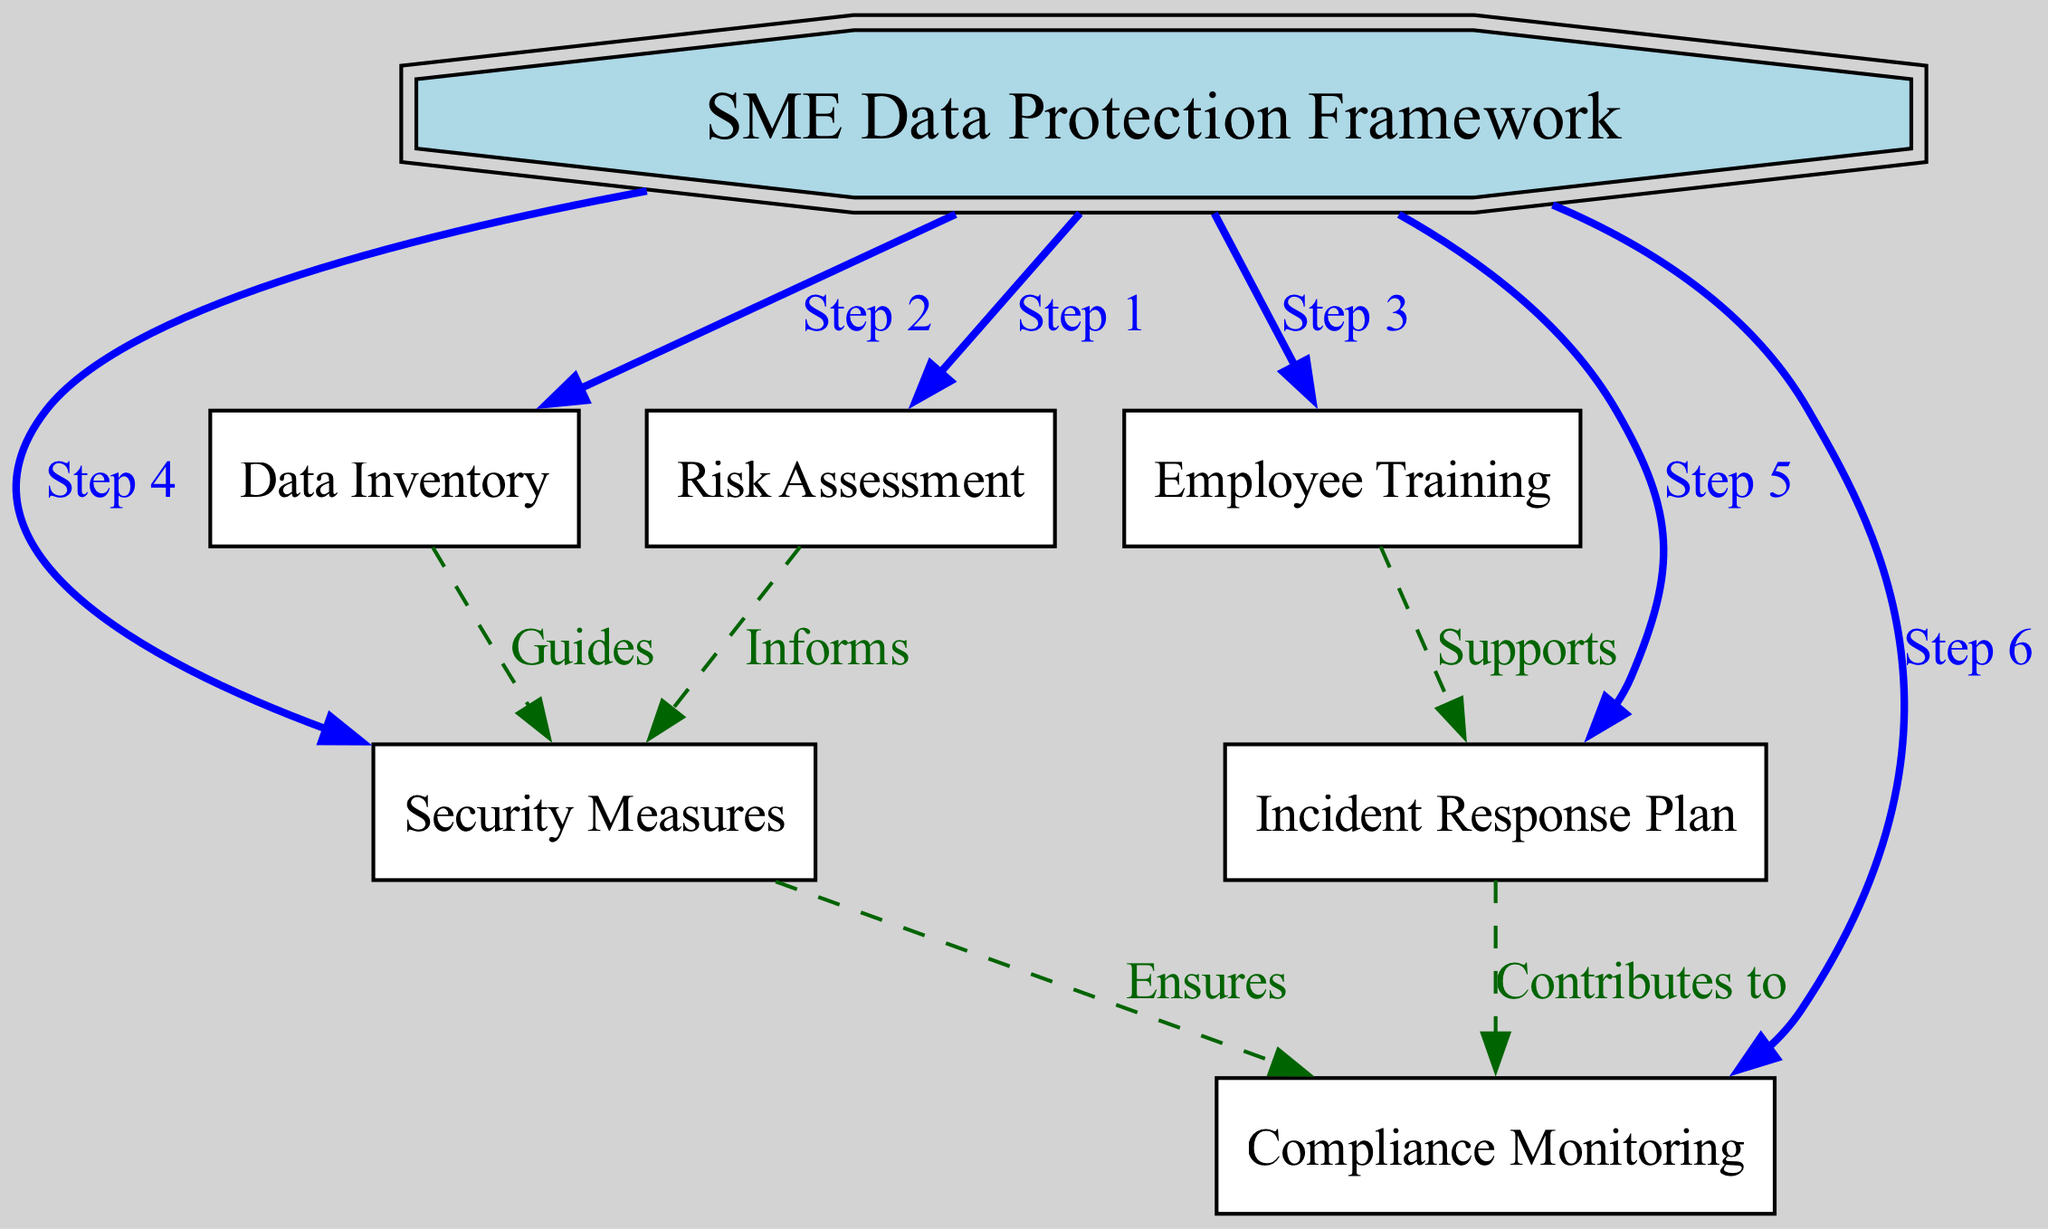What is the total number of nodes in the diagram? The diagram contains 7 nodes, which can be counted from the list of nodes provided.
Answer: 7 Which node represents the first step in the framework? The first step in the framework is represented by the "Risk Assessment" node, which is connected directly to the "SME Data Protection Framework" node.
Answer: Risk Assessment What is the relationship between "Employee Training" and "Incident Response Plan"? The "Employee Training" node supports the "Incident Response Plan" node, as shown by the directed edge labeled "Supports" connecting them.
Answer: Supports How many edges are there in total? The diagram lists 11 edges, each connecting various nodes as indicated. This can be counted from the edges provided.
Answer: 11 Which node is directly informed by the "Risk Assessment"? The "Security Measures" node is directly informed by the "Risk Assessment," indicated by the arrow labeled "Informs" leading from "Risk Assessment" to "Security Measures."
Answer: Security Measures What step follows after "Security Measures" in the framework? The step that follows after "Security Measures" is "Compliance Monitoring," connected by the directed edge labeled "Ensures."
Answer: Compliance Monitoring What is the last step in the Data Protection Framework? The last step in the framework is "Compliance Monitoring," which is the final action taken after the implementation of earlier steps.
Answer: Compliance Monitoring How does "Incident Response Plan" relate to "Compliance Monitoring"? The "Incident Response Plan" contributes to "Compliance Monitoring," as indicated by the edge labeled "Contributes to" leading from "Incident Response Plan" to "Compliance Monitoring."
Answer: Contributes to 